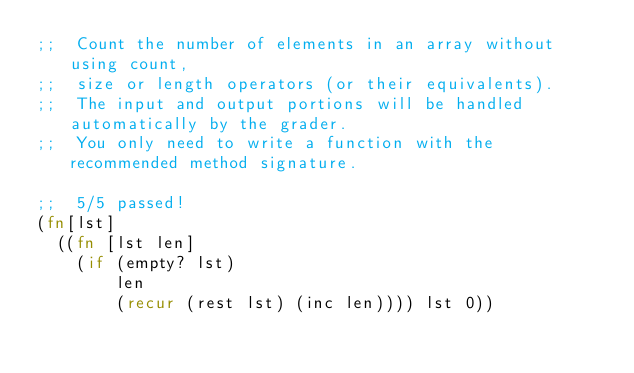Convert code to text. <code><loc_0><loc_0><loc_500><loc_500><_Clojure_>;;  Count the number of elements in an array without using count,
;;  size or length operators (or their equivalents).
;;  The input and output portions will be handled automatically by the grader.
;;  You only need to write a function with the recommended method signature.

;;  5/5 passed!
(fn[lst]
  ((fn [lst len]
    (if (empty? lst)
        len
        (recur (rest lst) (inc len)))) lst 0))
</code> 